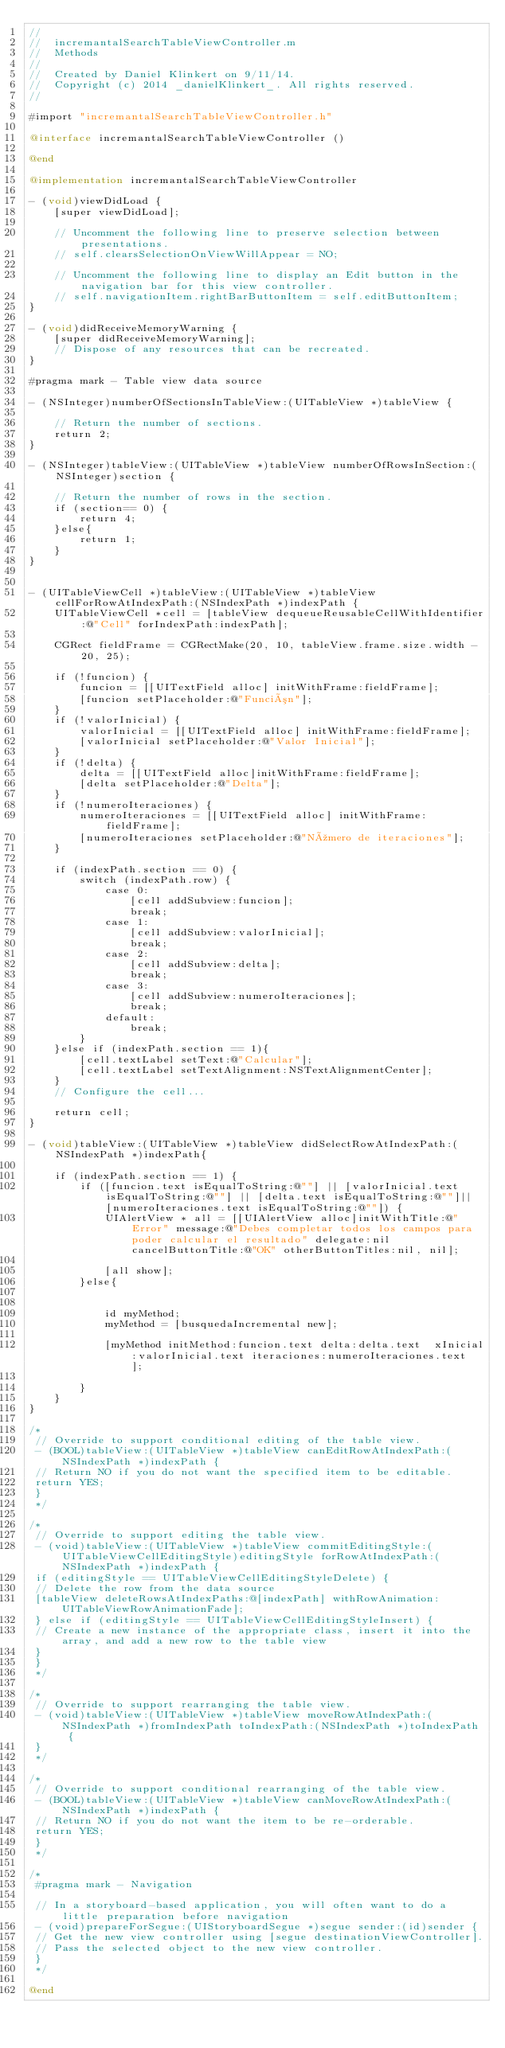Convert code to text. <code><loc_0><loc_0><loc_500><loc_500><_ObjectiveC_>//
//  incremantalSearchTableViewController.m
//  Methods
//
//  Created by Daniel Klinkert on 9/11/14.
//  Copyright (c) 2014 _danielKlinkert_. All rights reserved.
//

#import "incremantalSearchTableViewController.h"

@interface incremantalSearchTableViewController ()

@end

@implementation incremantalSearchTableViewController

- (void)viewDidLoad {
    [super viewDidLoad];
    
    // Uncomment the following line to preserve selection between presentations.
    // self.clearsSelectionOnViewWillAppear = NO;
    
    // Uncomment the following line to display an Edit button in the navigation bar for this view controller.
    // self.navigationItem.rightBarButtonItem = self.editButtonItem;
}

- (void)didReceiveMemoryWarning {
    [super didReceiveMemoryWarning];
    // Dispose of any resources that can be recreated.
}

#pragma mark - Table view data source

- (NSInteger)numberOfSectionsInTableView:(UITableView *)tableView {
    
    // Return the number of sections.
    return 2;
}

- (NSInteger)tableView:(UITableView *)tableView numberOfRowsInSection:(NSInteger)section {
    
    // Return the number of rows in the section.
    if (section== 0) {
        return 4;
    }else{
        return 1;
    }
}


- (UITableViewCell *)tableView:(UITableView *)tableView cellForRowAtIndexPath:(NSIndexPath *)indexPath {
    UITableViewCell *cell = [tableView dequeueReusableCellWithIdentifier:@"Cell" forIndexPath:indexPath];
    
    CGRect fieldFrame = CGRectMake(20, 10, tableView.frame.size.width - 20, 25);
    
    if (!funcion) {
        funcion = [[UITextField alloc] initWithFrame:fieldFrame];
        [funcion setPlaceholder:@"Función"];
    }
    if (!valorInicial) {
        valorInicial = [[UITextField alloc] initWithFrame:fieldFrame];
        [valorInicial setPlaceholder:@"Valor Inicial"];
    }
    if (!delta) {
        delta = [[UITextField alloc]initWithFrame:fieldFrame];
        [delta setPlaceholder:@"Delta"];
    }
    if (!numeroIteraciones) {
        numeroIteraciones = [[UITextField alloc] initWithFrame:fieldFrame];
        [numeroIteraciones setPlaceholder:@"Número de iteraciones"];
    }
    
    if (indexPath.section == 0) {
        switch (indexPath.row) {
            case 0:
                [cell addSubview:funcion];
                break;
            case 1:
                [cell addSubview:valorInicial];
                break;
            case 2:
                [cell addSubview:delta];
                break;
            case 3:
                [cell addSubview:numeroIteraciones];
                break;
            default:
                break;
        }
    }else if (indexPath.section == 1){
        [cell.textLabel setText:@"Calcular"];
        [cell.textLabel setTextAlignment:NSTextAlignmentCenter];
    }
    // Configure the cell...
    
    return cell;
}

- (void)tableView:(UITableView *)tableView didSelectRowAtIndexPath:(NSIndexPath *)indexPath{
    
    if (indexPath.section == 1) {
        if ([funcion.text isEqualToString:@""] || [valorInicial.text isEqualToString:@""] || [delta.text isEqualToString:@""]|| [numeroIteraciones.text isEqualToString:@""]) {
            UIAlertView * all = [[UIAlertView alloc]initWithTitle:@"Error" message:@"Debes completar todos los campos para poder calcular el resultado" delegate:nil cancelButtonTitle:@"OK" otherButtonTitles:nil, nil];
            
            [all show];
        }else{

            
            id myMethod;
            myMethod = [busquedaIncremental new];
            
            [myMethod initMethod:funcion.text delta:delta.text  xInicial:valorInicial.text iteraciones:numeroIteraciones.text ];
            
        }
    }
}

/*
 // Override to support conditional editing of the table view.
 - (BOOL)tableView:(UITableView *)tableView canEditRowAtIndexPath:(NSIndexPath *)indexPath {
 // Return NO if you do not want the specified item to be editable.
 return YES;
 }
 */

/*
 // Override to support editing the table view.
 - (void)tableView:(UITableView *)tableView commitEditingStyle:(UITableViewCellEditingStyle)editingStyle forRowAtIndexPath:(NSIndexPath *)indexPath {
 if (editingStyle == UITableViewCellEditingStyleDelete) {
 // Delete the row from the data source
 [tableView deleteRowsAtIndexPaths:@[indexPath] withRowAnimation:UITableViewRowAnimationFade];
 } else if (editingStyle == UITableViewCellEditingStyleInsert) {
 // Create a new instance of the appropriate class, insert it into the array, and add a new row to the table view
 }
 }
 */

/*
 // Override to support rearranging the table view.
 - (void)tableView:(UITableView *)tableView moveRowAtIndexPath:(NSIndexPath *)fromIndexPath toIndexPath:(NSIndexPath *)toIndexPath {
 }
 */

/*
 // Override to support conditional rearranging of the table view.
 - (BOOL)tableView:(UITableView *)tableView canMoveRowAtIndexPath:(NSIndexPath *)indexPath {
 // Return NO if you do not want the item to be re-orderable.
 return YES;
 }
 */

/*
 #pragma mark - Navigation
 
 // In a storyboard-based application, you will often want to do a little preparation before navigation
 - (void)prepareForSegue:(UIStoryboardSegue *)segue sender:(id)sender {
 // Get the new view controller using [segue destinationViewController].
 // Pass the selected object to the new view controller.
 }
 */

@end
</code> 